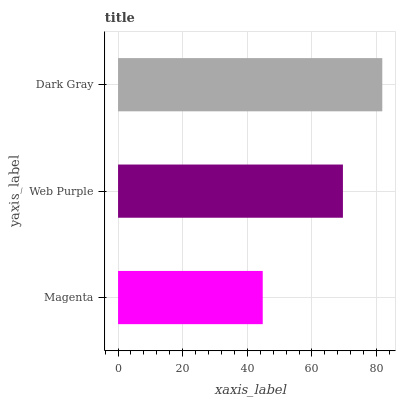Is Magenta the minimum?
Answer yes or no. Yes. Is Dark Gray the maximum?
Answer yes or no. Yes. Is Web Purple the minimum?
Answer yes or no. No. Is Web Purple the maximum?
Answer yes or no. No. Is Web Purple greater than Magenta?
Answer yes or no. Yes. Is Magenta less than Web Purple?
Answer yes or no. Yes. Is Magenta greater than Web Purple?
Answer yes or no. No. Is Web Purple less than Magenta?
Answer yes or no. No. Is Web Purple the high median?
Answer yes or no. Yes. Is Web Purple the low median?
Answer yes or no. Yes. Is Dark Gray the high median?
Answer yes or no. No. Is Magenta the low median?
Answer yes or no. No. 